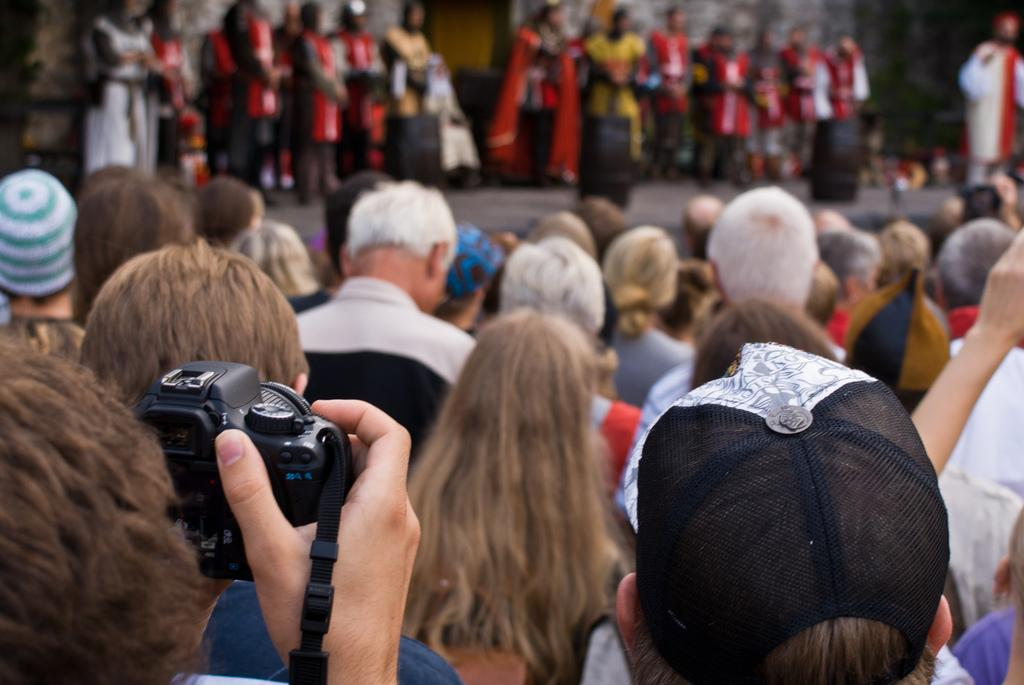How many people are in the image? There is a group of people in the image. What is one person in the group holding? One person is holding a camera in their hand. What type of guitar is being played by the person in the image? There is no guitar present in the image; only a group of people and a person holding a camera are visible. 